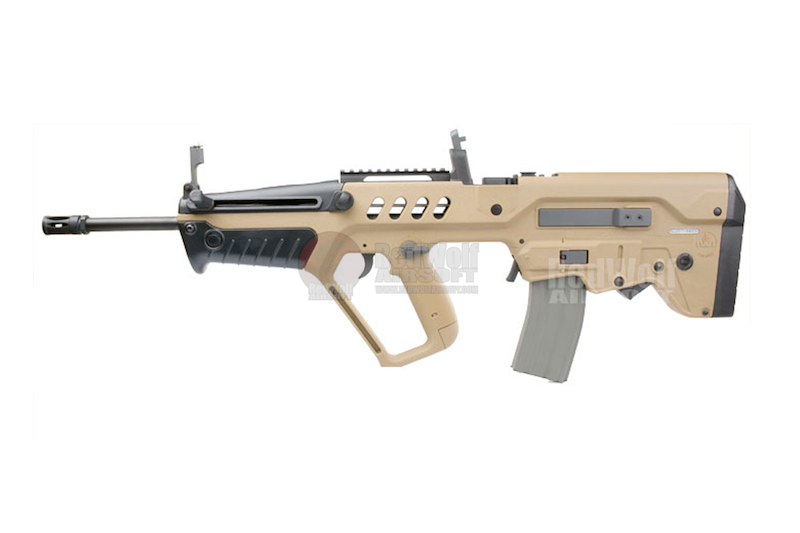If this firearm could talk, what stories might it tell about its usage in the field? If this firearm could talk, it might recount tales of rigorous training exercises, showcasing its precision and reliability. It would tell stories of its various deployments, from urban environments to rugged terrains, where its compact design proved advantageous. The firearm might also share experiences of soldiers depending on its accuracy during critical missions, valuing its customized optics and ergonomic features that ensured steadiness and control. It could also recall moments of quick target acquisition under intense conditions, highlighting the importance of its integrated iron sights. 